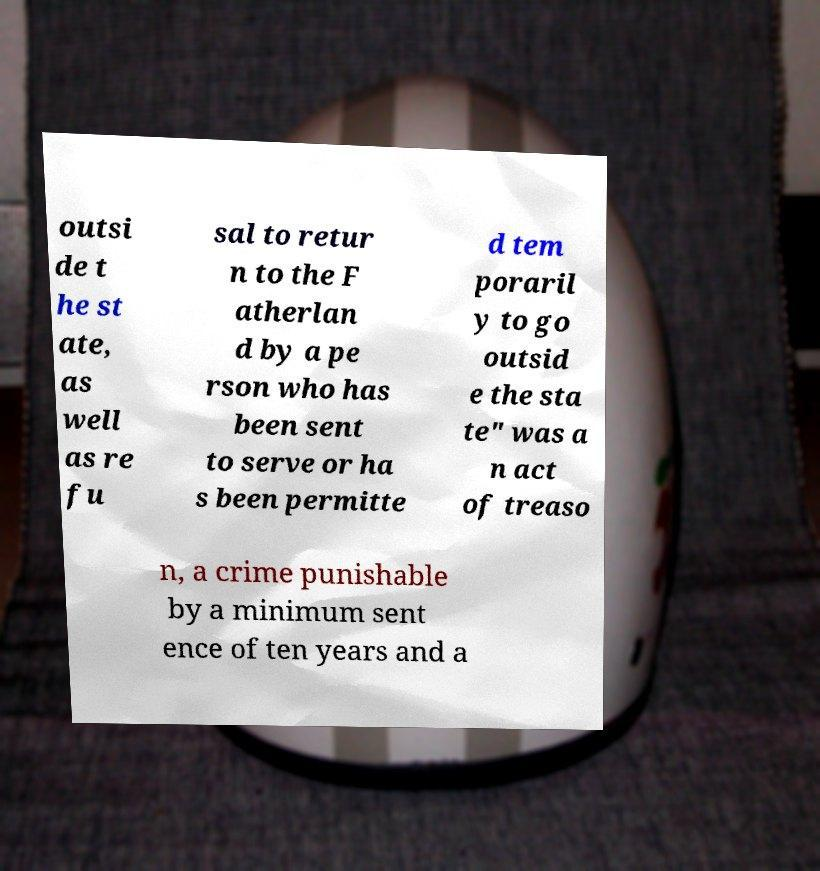I need the written content from this picture converted into text. Can you do that? outsi de t he st ate, as well as re fu sal to retur n to the F atherlan d by a pe rson who has been sent to serve or ha s been permitte d tem poraril y to go outsid e the sta te" was a n act of treaso n, a crime punishable by a minimum sent ence of ten years and a 